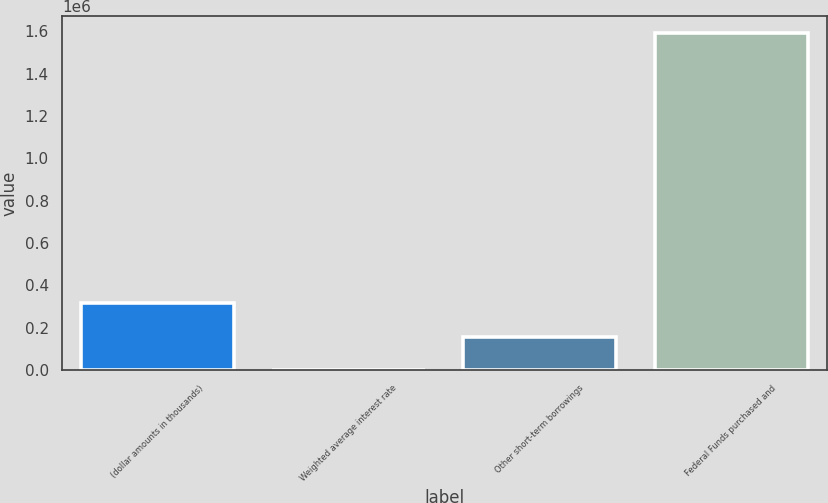Convert chart. <chart><loc_0><loc_0><loc_500><loc_500><bar_chart><fcel>(dollar amounts in thousands)<fcel>Weighted average interest rate<fcel>Other short-term borrowings<fcel>Federal Funds purchased and<nl><fcel>318017<fcel>0.15<fcel>159008<fcel>1.59008e+06<nl></chart> 